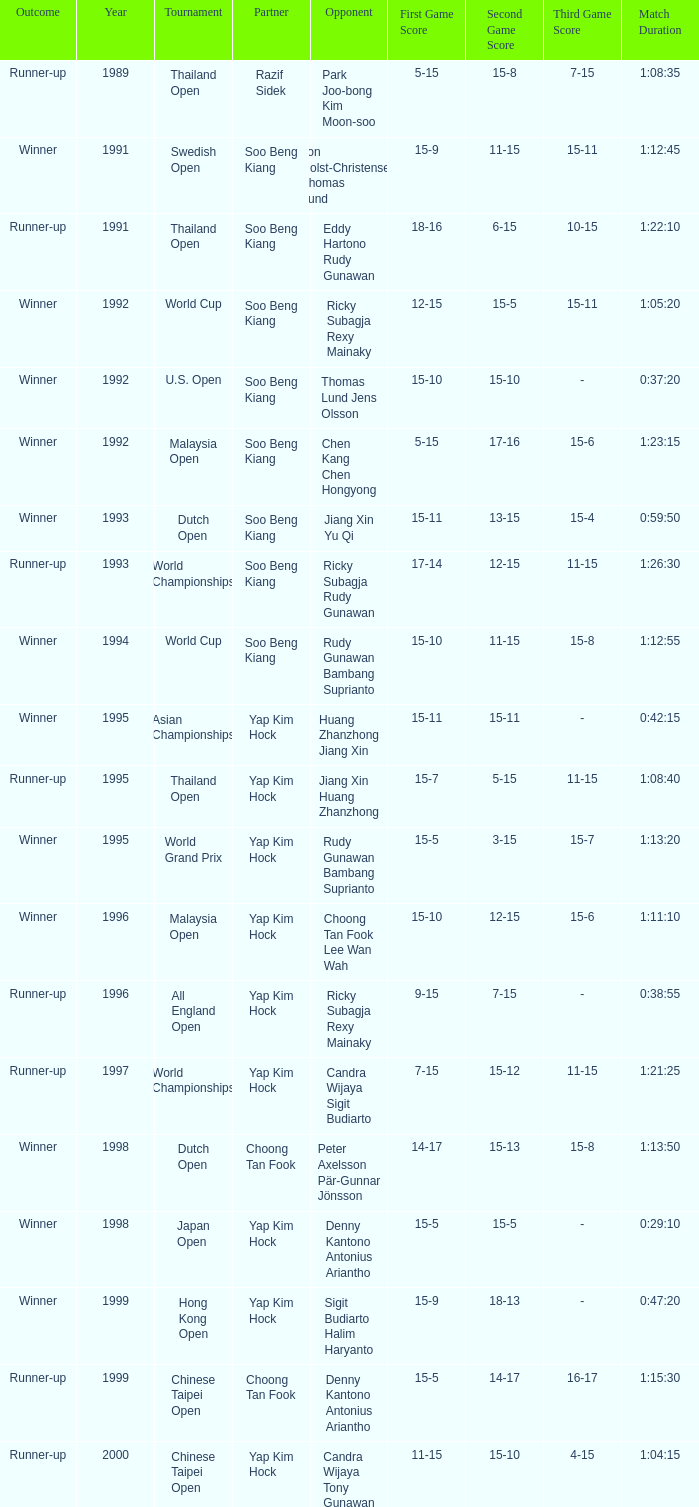Which opponent played in the Chinese Taipei Open in 2000? Candra Wijaya Tony Gunawan. 